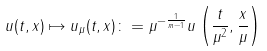Convert formula to latex. <formula><loc_0><loc_0><loc_500><loc_500>u ( t , x ) \mapsto u _ { \mu } ( t , x ) \colon = \mu ^ { - \frac { 1 } { m - 1 } } u \left ( \frac { t } { \mu ^ { 2 } } , \frac { x } { \mu } \right )</formula> 